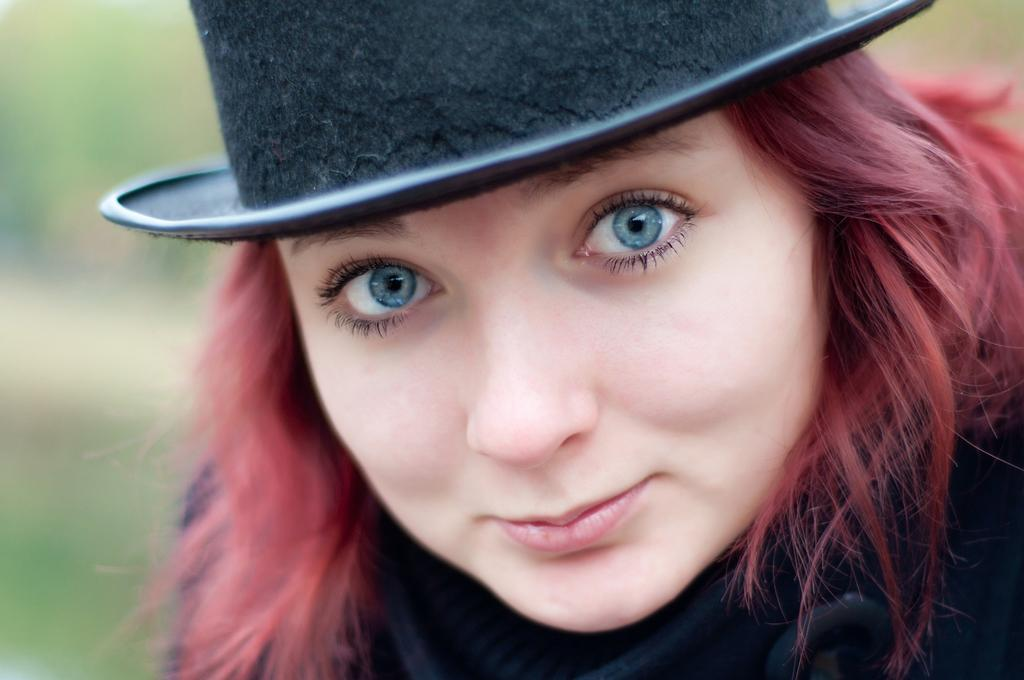Who is the main subject in the image? There is a lady in the image. What is the lady wearing on her head? The lady is wearing a black hat. What color are the lady's eyes? The lady has blue eyes. Can you describe the background of the image? The background of the image is blurred. What type of quiver can be seen on the lady's arm in the image? There is no quiver or arm visible in the image; it only features a lady with a black hat and blue eyes against a blurred background. 